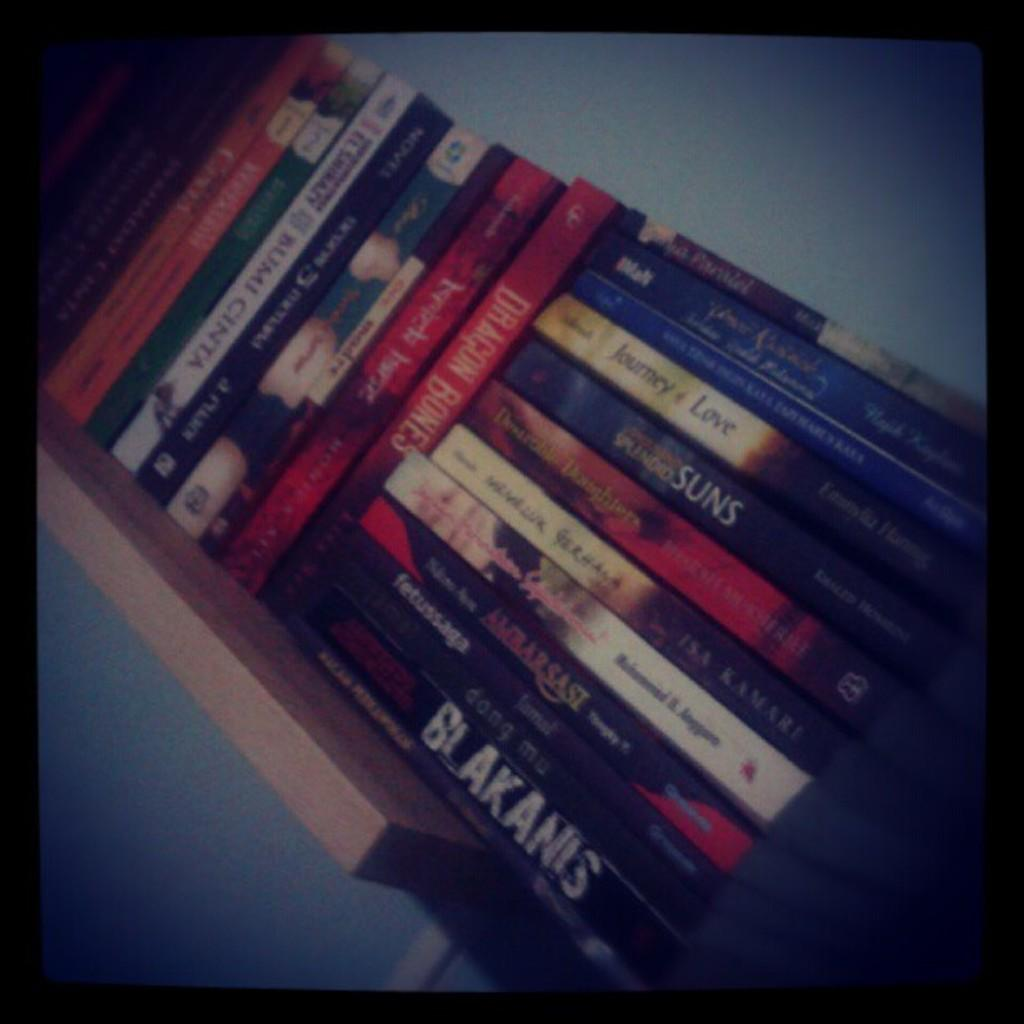<image>
Relay a brief, clear account of the picture shown. A shelf full of various books with one of the books titled Blakanis. 